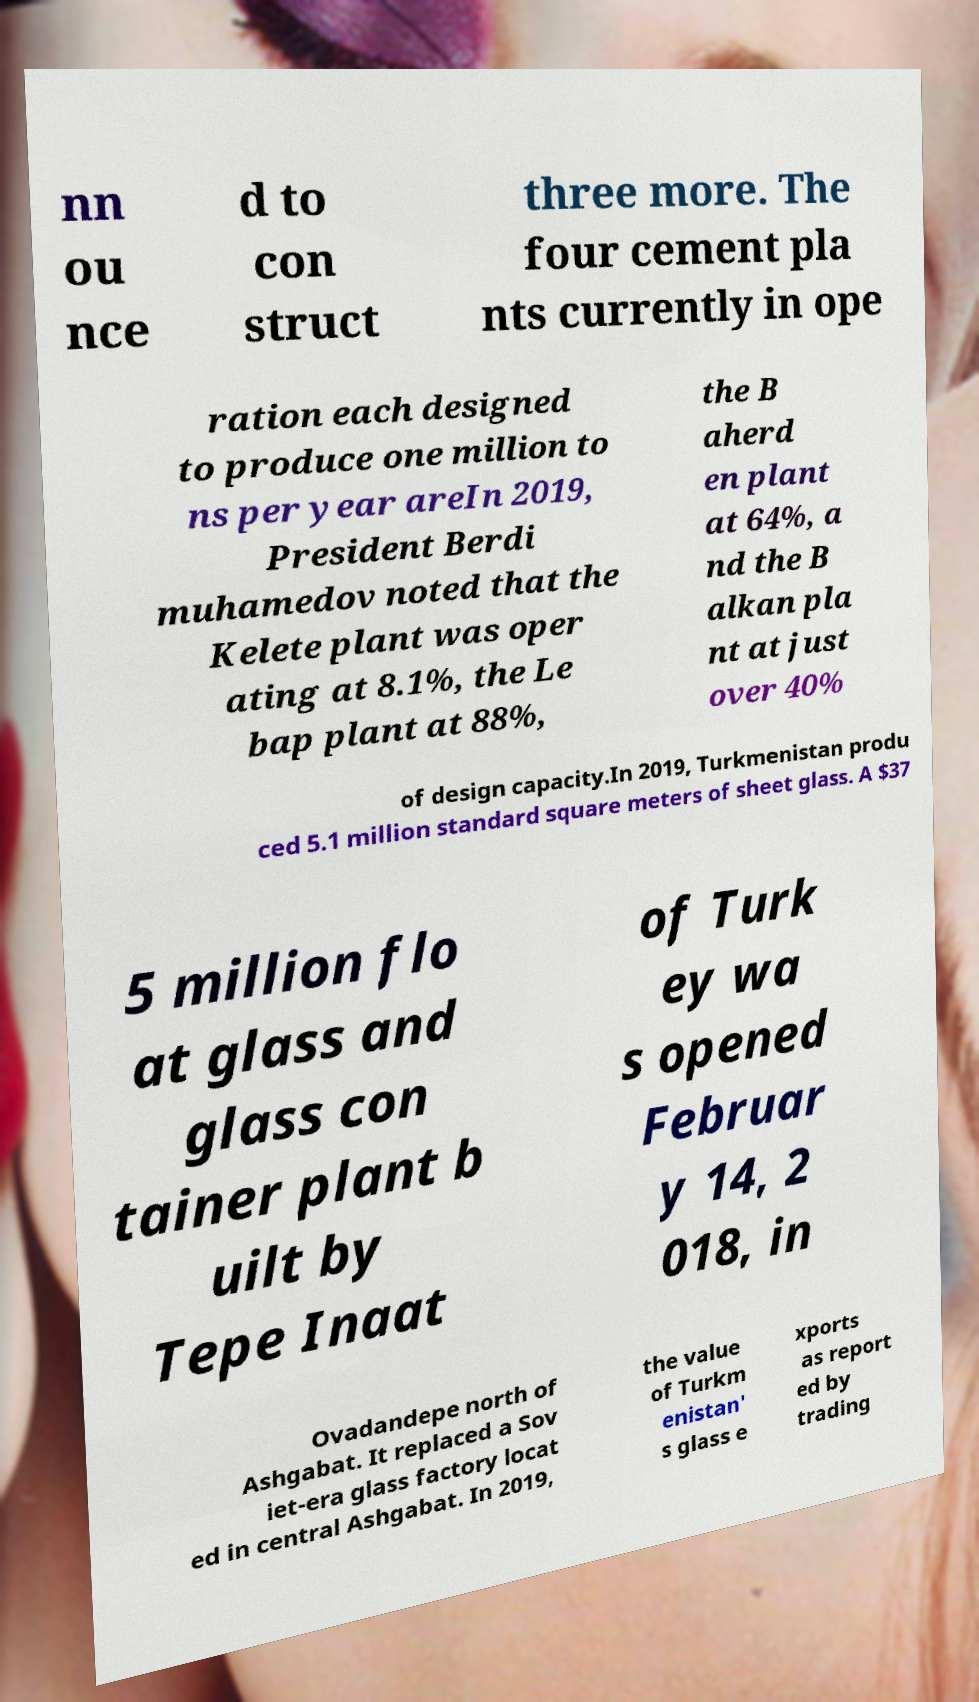Could you extract and type out the text from this image? nn ou nce d to con struct three more. The four cement pla nts currently in ope ration each designed to produce one million to ns per year areIn 2019, President Berdi muhamedov noted that the Kelete plant was oper ating at 8.1%, the Le bap plant at 88%, the B aherd en plant at 64%, a nd the B alkan pla nt at just over 40% of design capacity.In 2019, Turkmenistan produ ced 5.1 million standard square meters of sheet glass. A $37 5 million flo at glass and glass con tainer plant b uilt by Tepe Inaat of Turk ey wa s opened Februar y 14, 2 018, in Ovadandepe north of Ashgabat. It replaced a Sov iet-era glass factory locat ed in central Ashgabat. In 2019, the value of Turkm enistan' s glass e xports as report ed by trading 